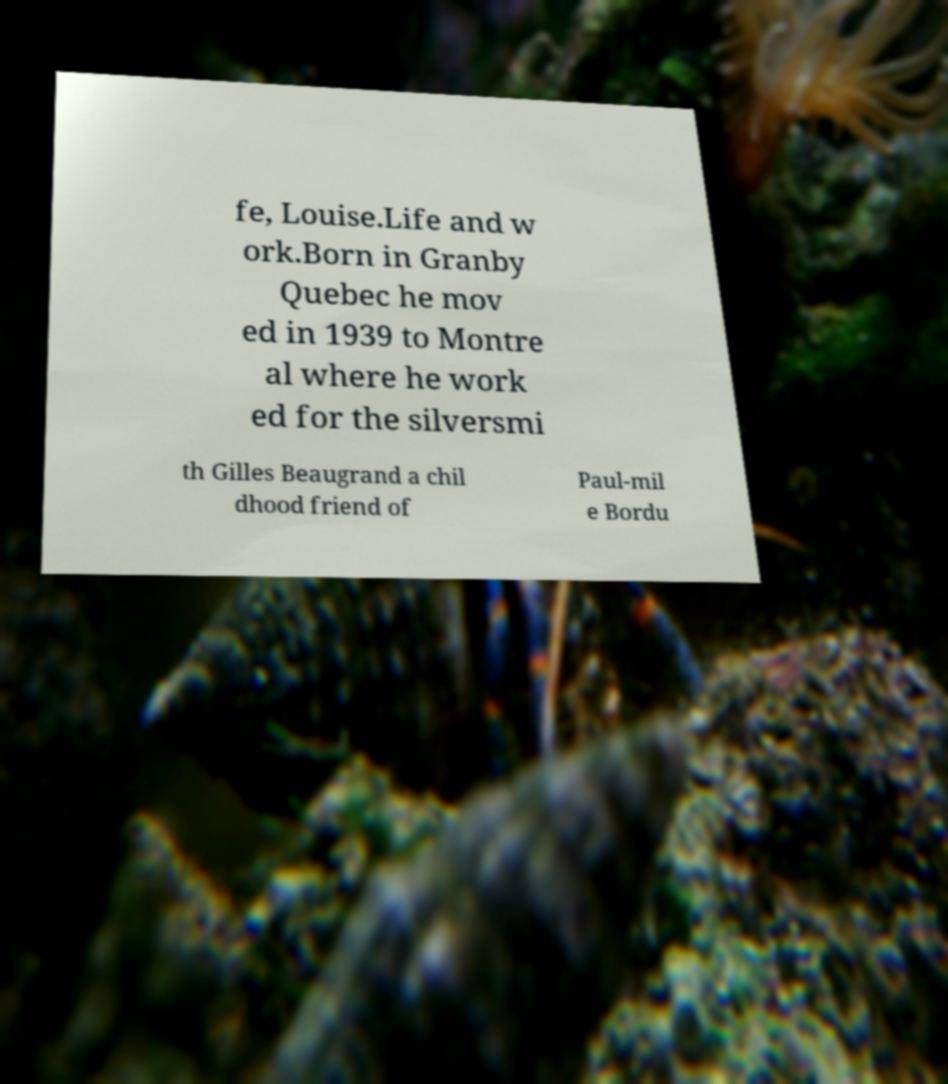What messages or text are displayed in this image? I need them in a readable, typed format. fe, Louise.Life and w ork.Born in Granby Quebec he mov ed in 1939 to Montre al where he work ed for the silversmi th Gilles Beaugrand a chil dhood friend of Paul-mil e Bordu 